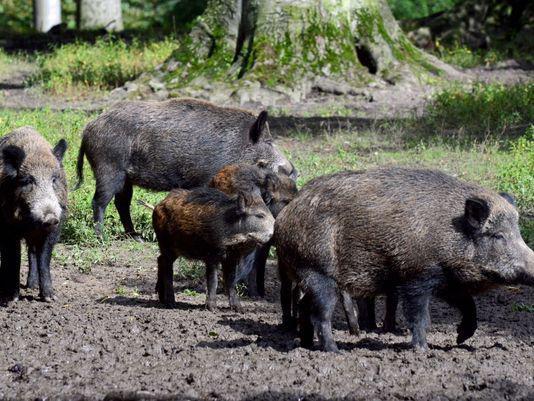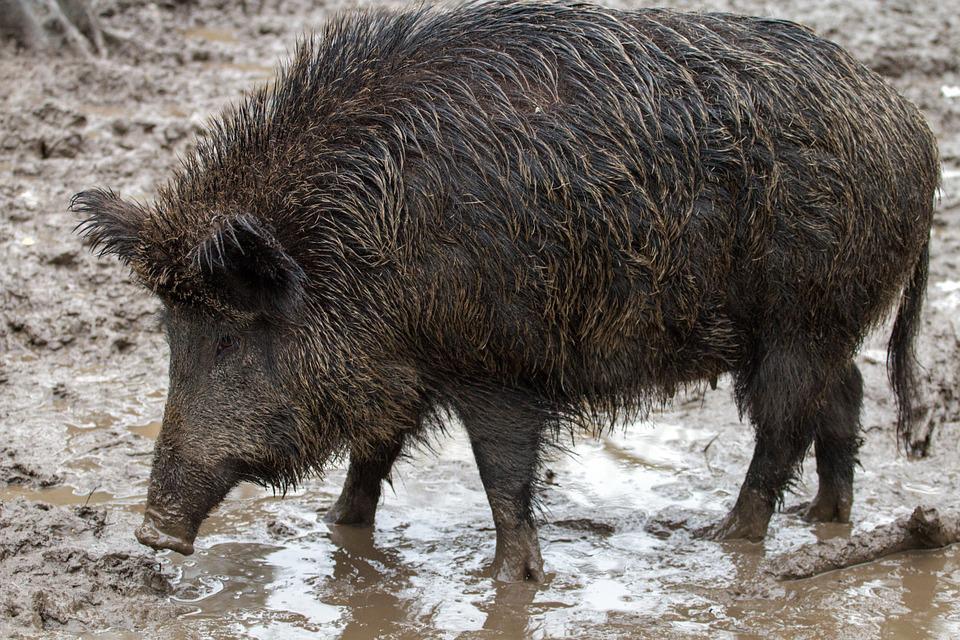The first image is the image on the left, the second image is the image on the right. Assess this claim about the two images: "A boar is facing forward in one image and to the right in the other.". Correct or not? Answer yes or no. No. The first image is the image on the left, the second image is the image on the right. Analyze the images presented: Is the assertion "The pig in the left image is not alone." valid? Answer yes or no. Yes. 